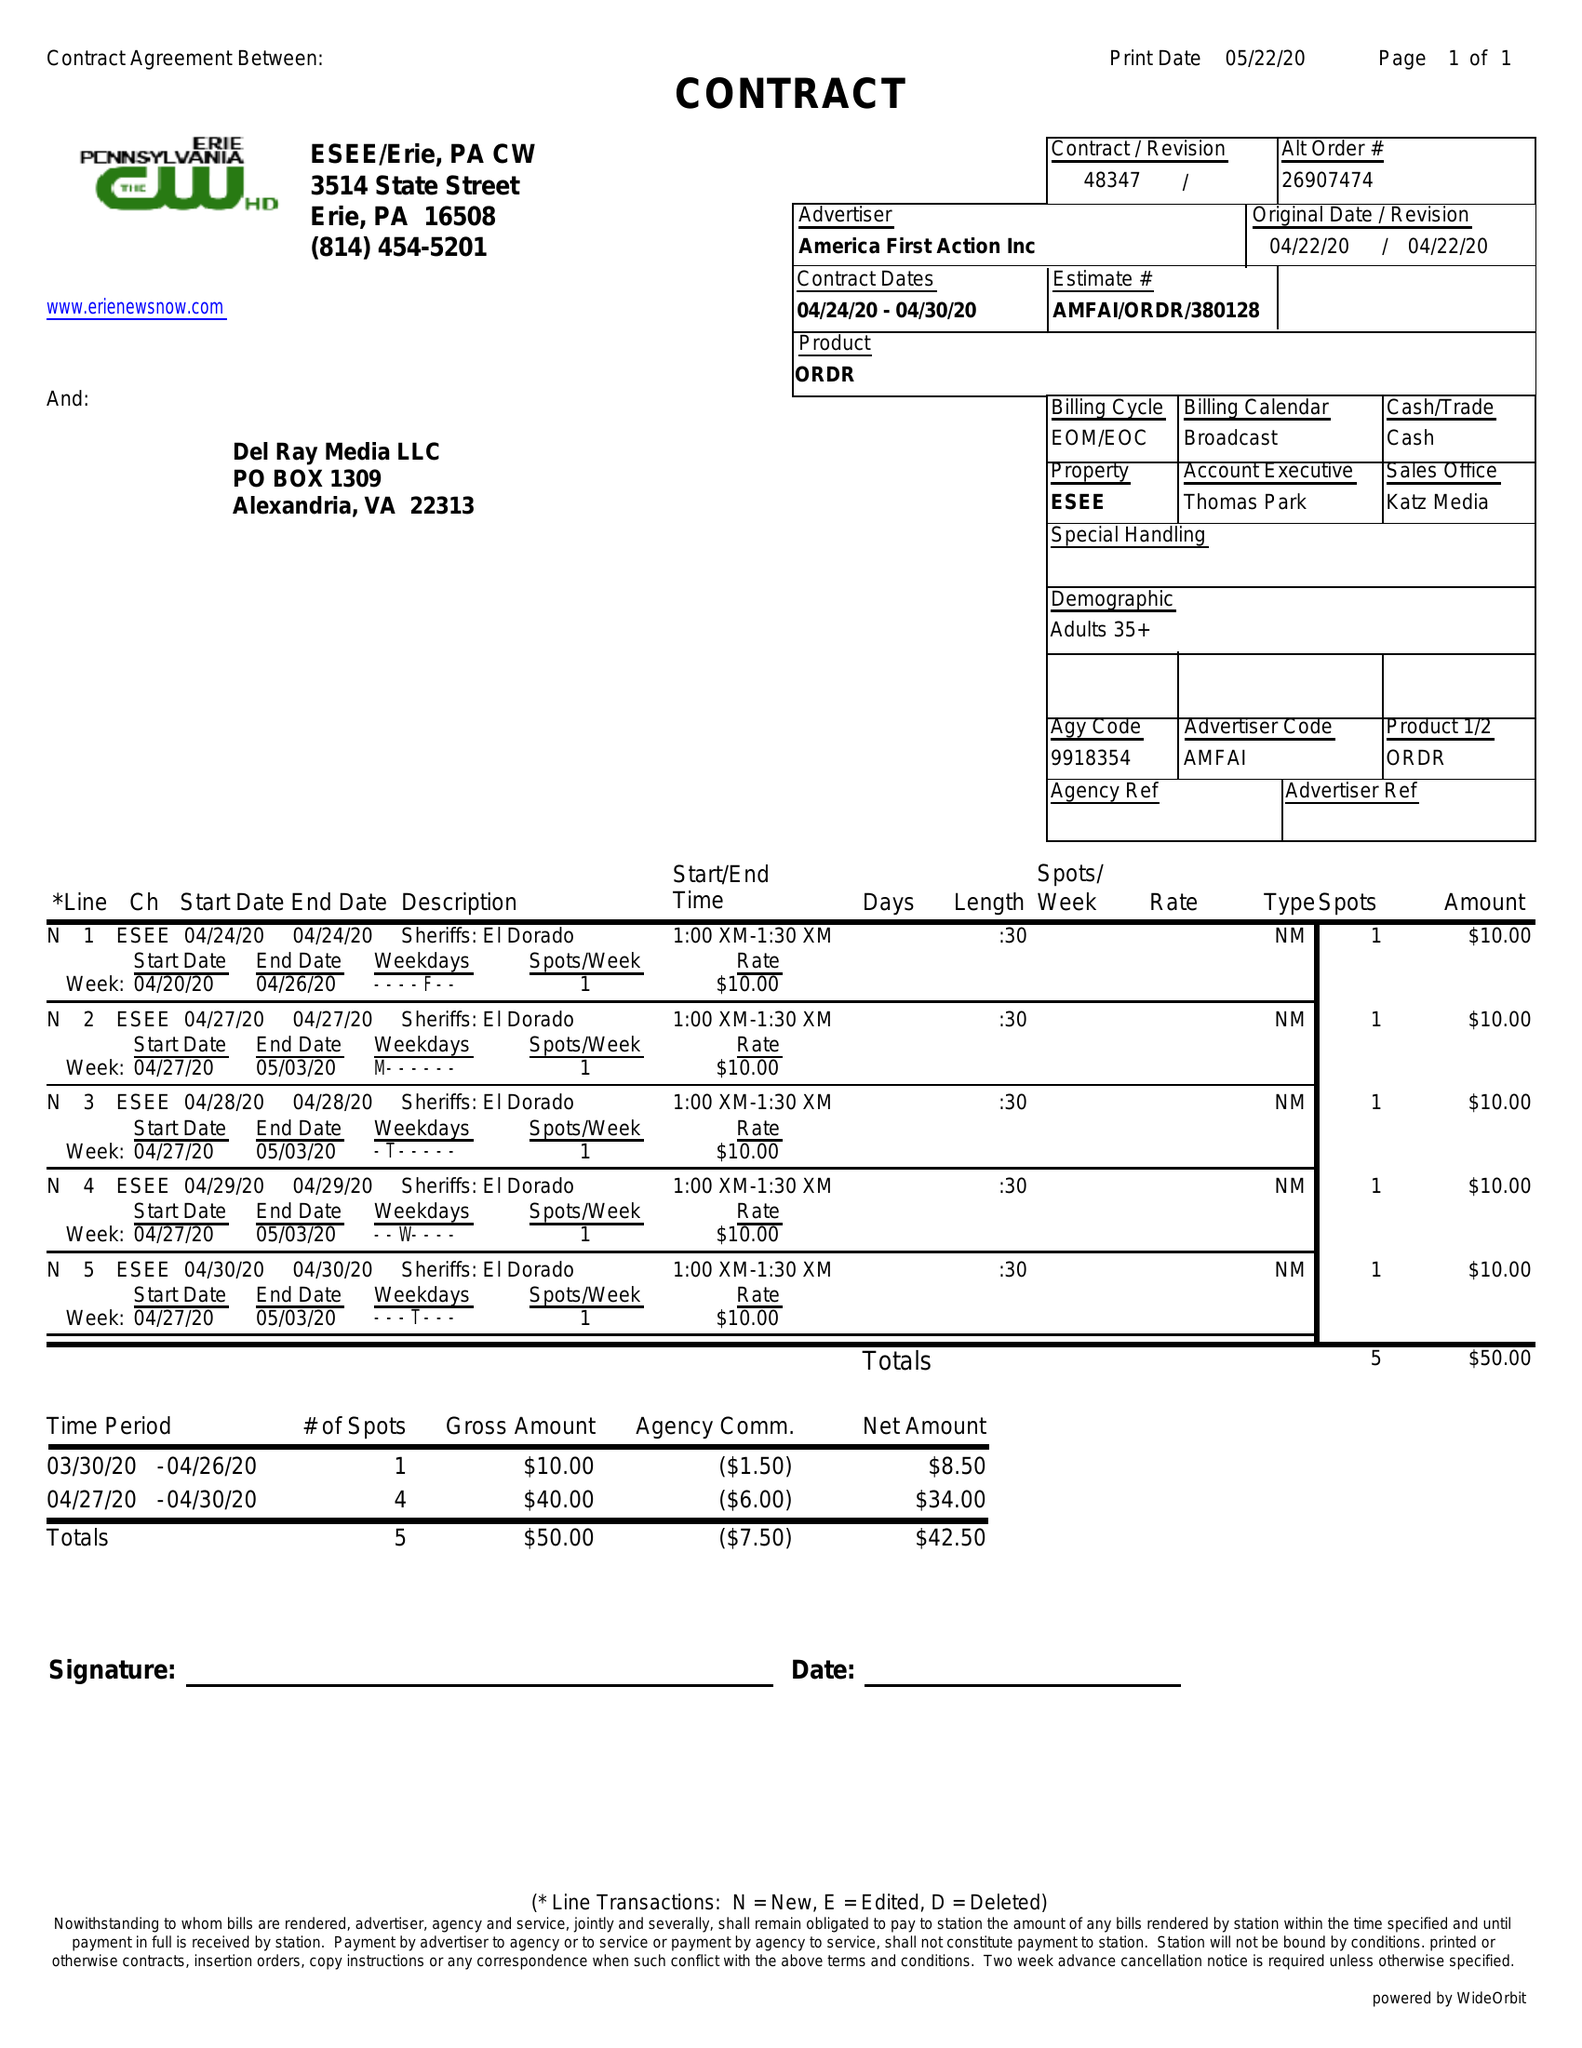What is the value for the flight_from?
Answer the question using a single word or phrase. 04/24/20 